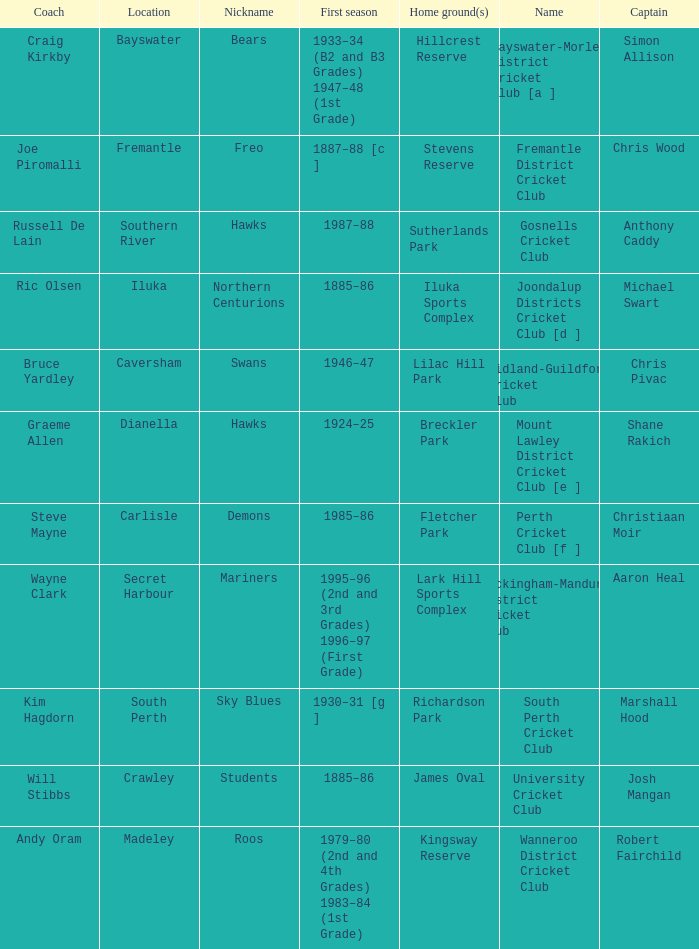For location Caversham, what is the name of the captain? Chris Pivac. 